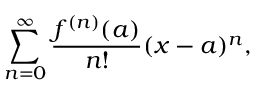<formula> <loc_0><loc_0><loc_500><loc_500>\sum _ { n = 0 } ^ { \infty } { \frac { f ^ { ( n ) } ( a ) } { n ! } } ( x - a ) ^ { n } ,</formula> 